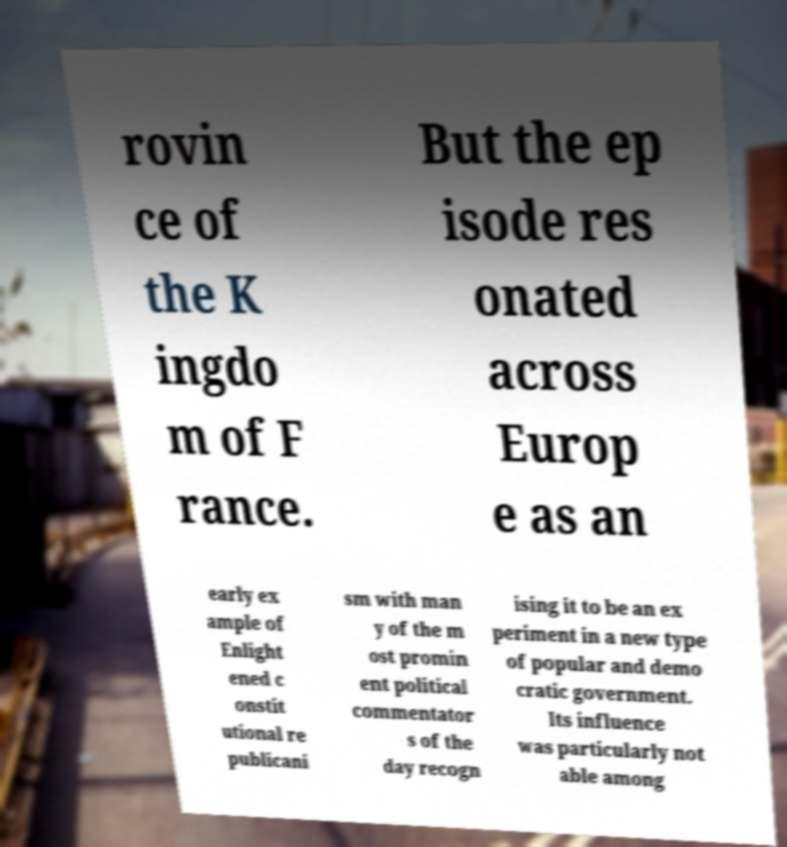For documentation purposes, I need the text within this image transcribed. Could you provide that? rovin ce of the K ingdo m of F rance. But the ep isode res onated across Europ e as an early ex ample of Enlight ened c onstit utional re publicani sm with man y of the m ost promin ent political commentator s of the day recogn ising it to be an ex periment in a new type of popular and demo cratic government. Its influence was particularly not able among 